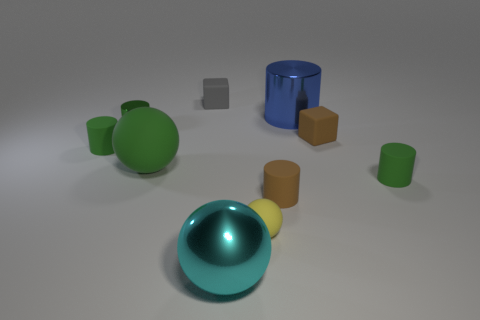Subtract all green cylinders. How many were subtracted if there are1green cylinders left? 2 Subtract all brown balls. How many green cylinders are left? 3 Subtract all green matte spheres. How many spheres are left? 2 Subtract all brown cylinders. How many cylinders are left? 4 Subtract all spheres. How many objects are left? 7 Subtract all gray spheres. Subtract all purple blocks. How many spheres are left? 3 Add 2 cyan things. How many cyan things are left? 3 Add 1 tiny balls. How many tiny balls exist? 2 Subtract 0 cyan blocks. How many objects are left? 10 Subtract all big yellow matte cylinders. Subtract all metallic spheres. How many objects are left? 9 